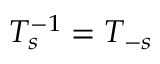<formula> <loc_0><loc_0><loc_500><loc_500>T _ { s } ^ { - 1 } = T _ { - s }</formula> 